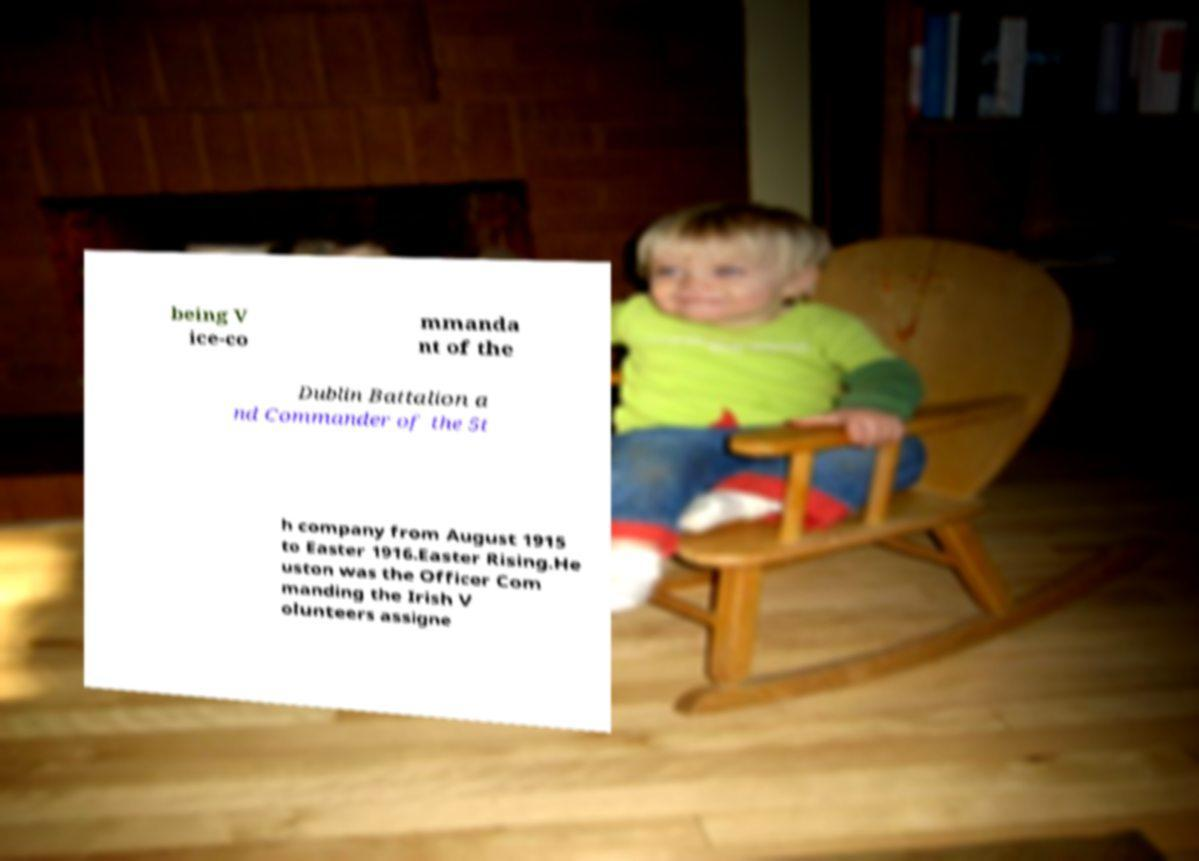What messages or text are displayed in this image? I need them in a readable, typed format. being V ice-co mmanda nt of the Dublin Battalion a nd Commander of the 5t h company from August 1915 to Easter 1916.Easter Rising.He uston was the Officer Com manding the Irish V olunteers assigne 